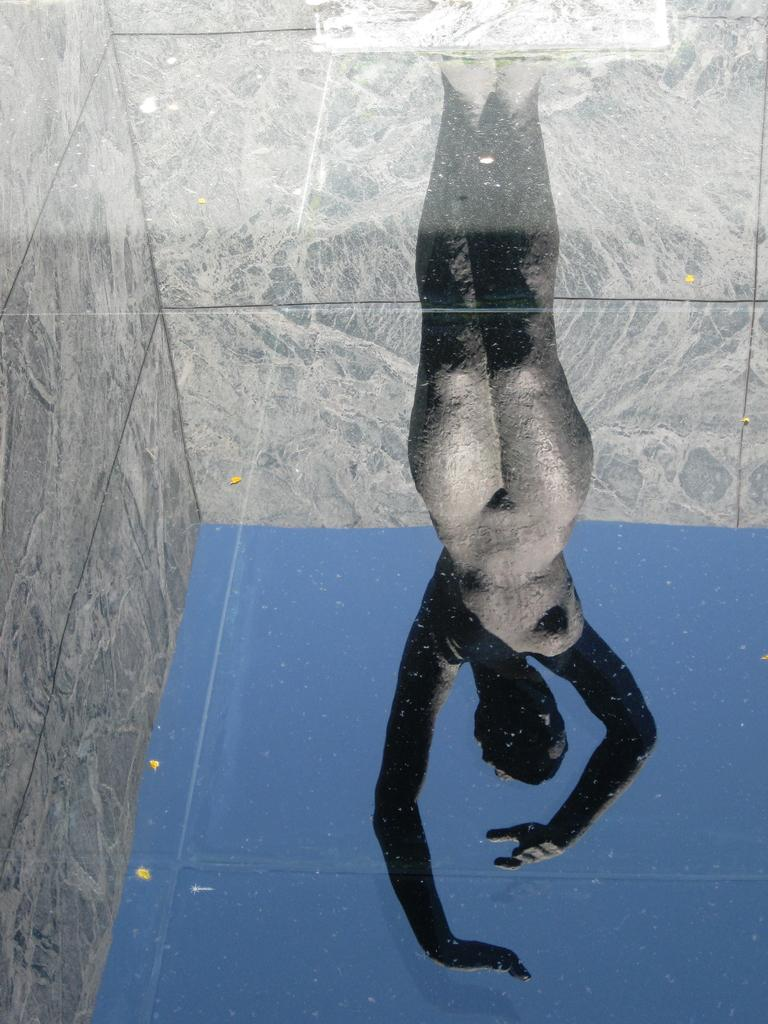What object is present in the image that can hold a liquid? There is a glass in the image. What can be seen through the glass? A statue of a person is visible through the glass. What type of structure is present in the image? There is a wall in the image. What is visible in the background of the image? The sky is visible in the image. How many apples are on the leg of the statue in the image? There is no mention of apples or legs in the image, so it is not possible to answer that question. 